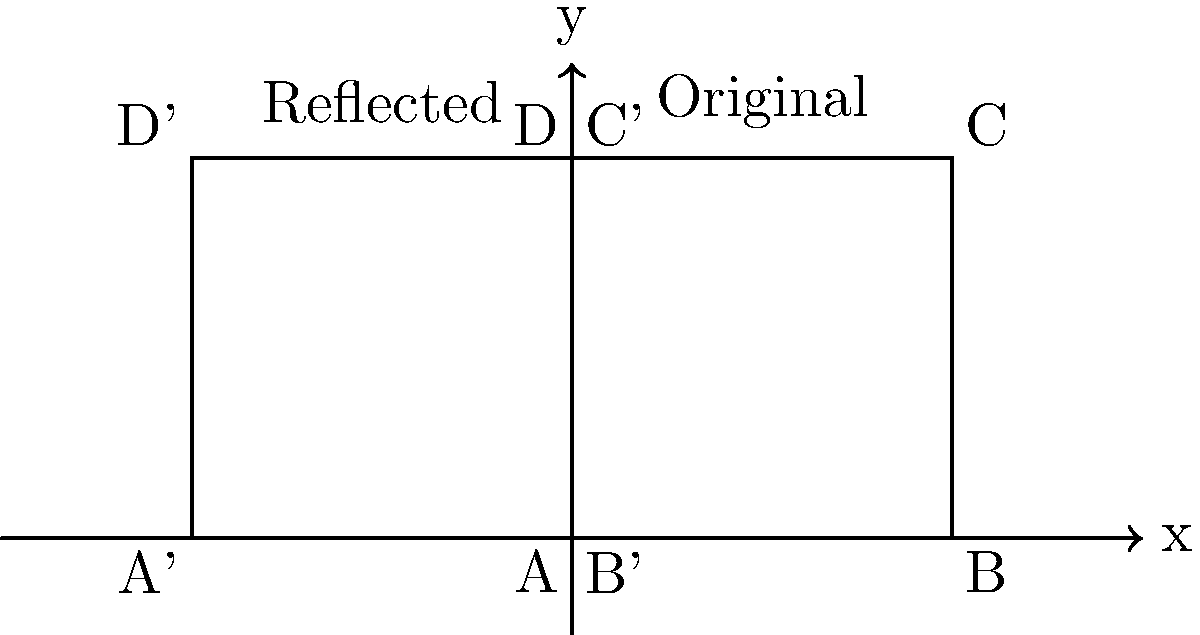In the context of reversing malicious code, how does the process of reflecting a figure across the y-axis relate to the concept of reversing the flow of execution in Python code? Consider the transformation shown in the diagram and explain how this geometric operation can be analogous to a specific code security review technique. 1. Geometric Reflection:
   - The diagram shows a square ABCD reflected across the y-axis to form A'B'C'D'.
   - This reflection reverses the x-coordinates while keeping y-coordinates unchanged.

2. Code Execution Flow:
   - In Python, code typically executes from top to bottom, left to right.
   - Malicious code often obfuscates this flow to hide its true intentions.

3. Analogy to Code Reversal:
   - Reflecting across the y-axis is similar to reversing the order of operations in code.
   - Just as the reflection flips the figure horizontally, code reversal flips the execution order.

4. Application in Code Security Review:
   - When reviewing potentially malicious Python code, security experts often need to mentally "reflect" or reverse the flow of execution.
   - This process involves:
     a) Identifying the final state or output of the code.
     b) Working backwards to understand how that state was achieved.
     c) Revealing hidden operations or obfuscated logic.

5. Example in Python:
   - Consider a simple obfuscated code:
     ```python
     x = lambda a : a[::-1]
     y = x("edoc suoicilam")
     print(y)
     ```
   - Reversing the flow (reflecting) reveals:
     a) The output is "malicious code"
     b) The lambda function reverses the string
     c) The original input was obfuscated

6. Geometric Parallel:
   - Just as reflecting ABCD across the y-axis produces A'B'C'D', reversing the code execution produces the original, unobfuscated intent.

7. Security Implication:
   - This "reflection" technique in code review helps identify potentially harmful operations that may not be immediately apparent in forward execution.
Answer: Reflecting across y-axis parallels reversing code execution flow, revealing obfuscated logic and hidden malicious intent. 